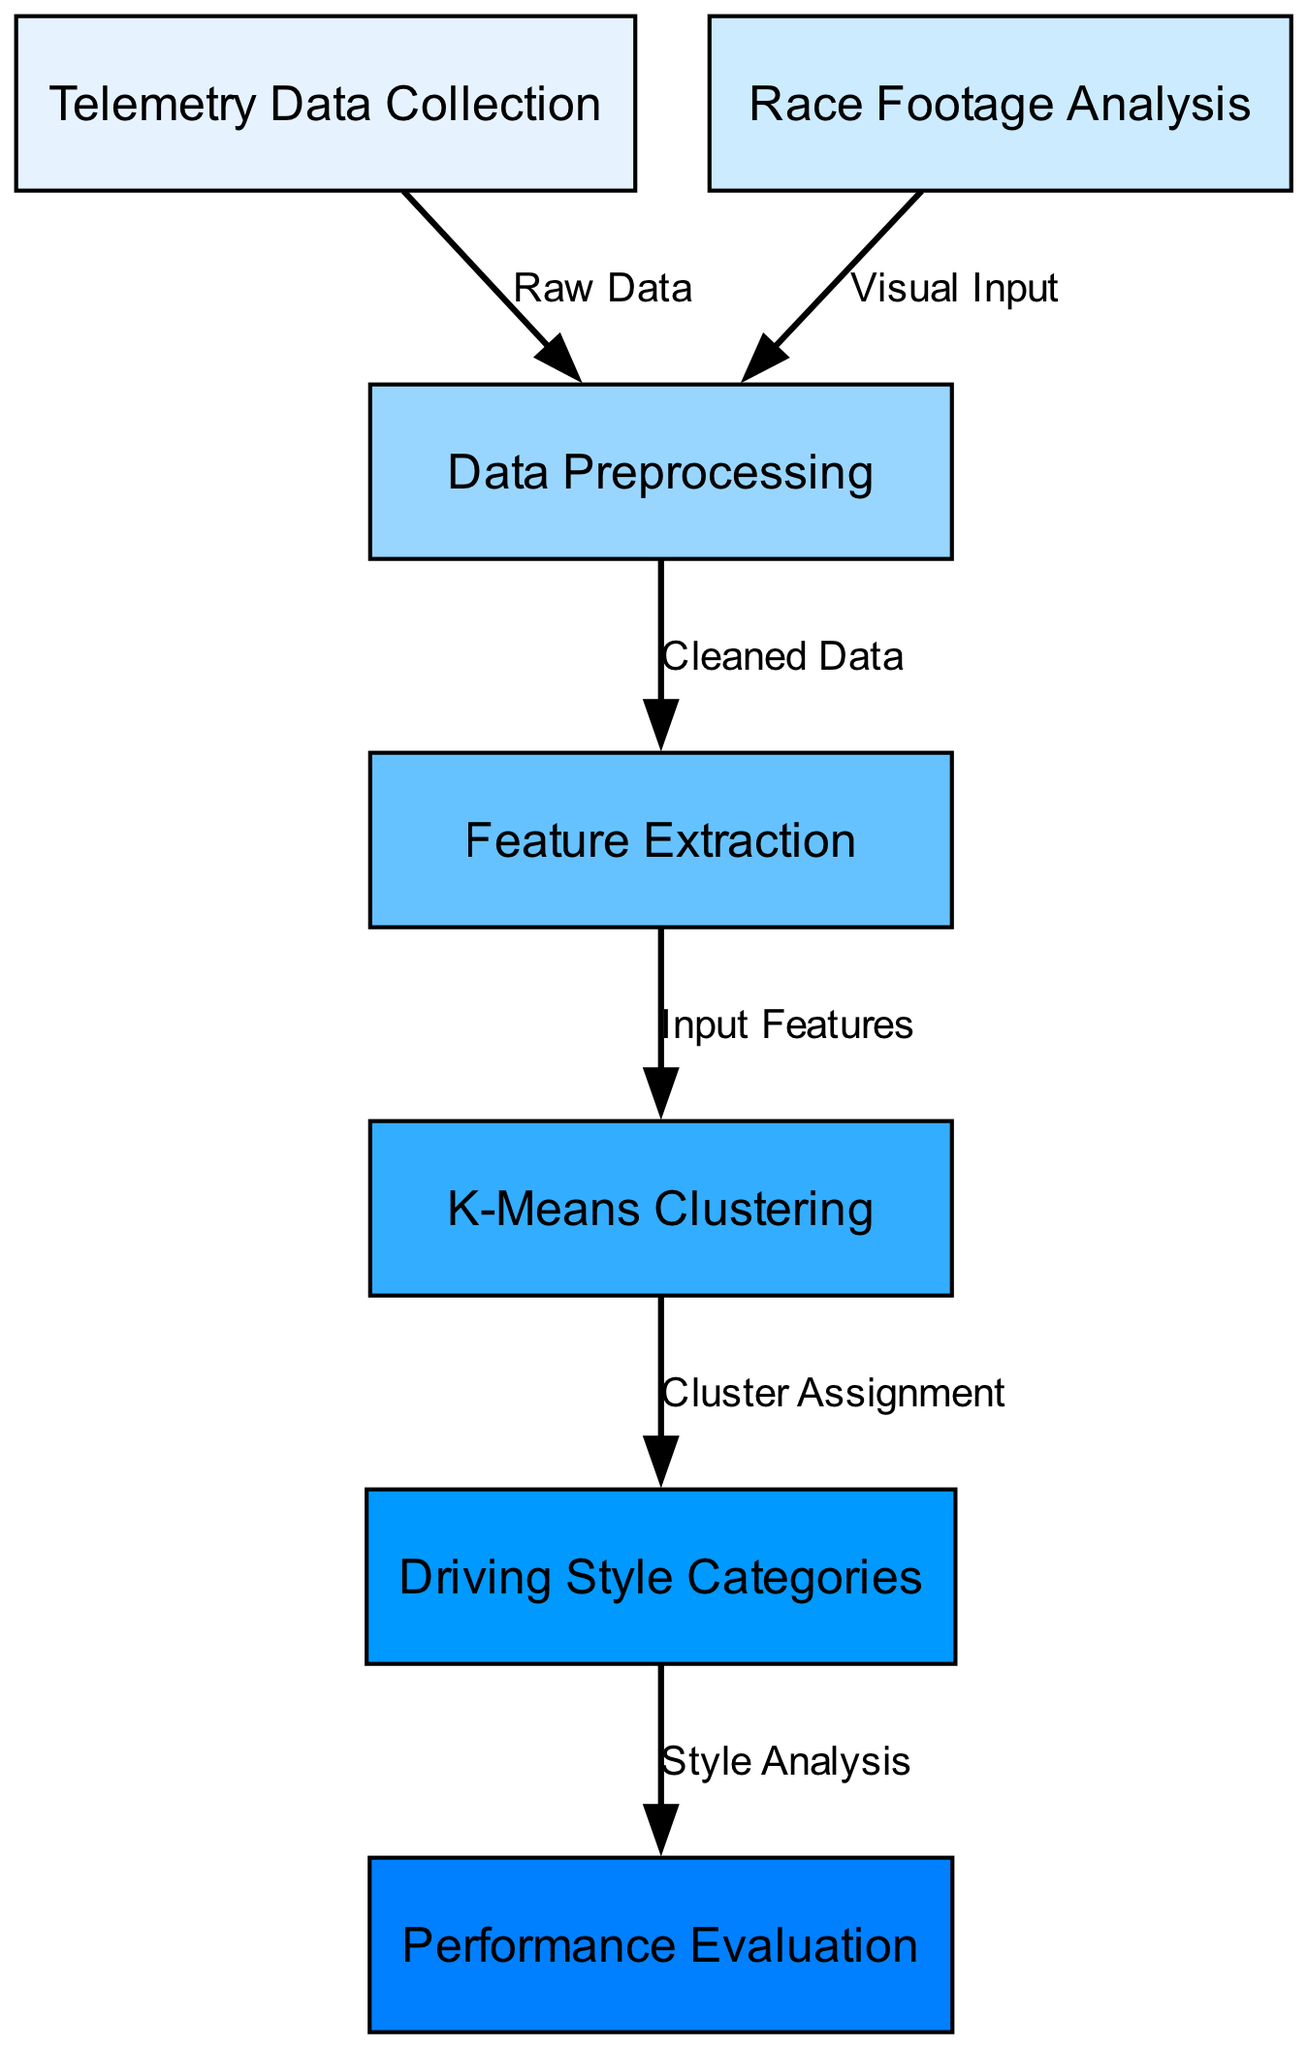What is the first node in the diagram? The first node is "Telemetry Data Collection," which is identified as the starting point of the process in the leftmost position of the diagram.
Answer: Telemetry Data Collection How many nodes are present in the diagram? The diagram contains a total of seven nodes, each representing a distinct component in the workflow.
Answer: 7 What type of data does the edge from node 1 represent? The edge from "Telemetry Data Collection" leads to "Data Preprocessing" and is labeled "Raw Data," indicating that the raw telemetry data is used for further processing.
Answer: Raw Data Which node receives input from both telemetry data and race footage? The "Data Preprocessing" node receives raw data from telemetry and visual input from race footage, which is pointed out by two incoming edges to that node.
Answer: Data Preprocessing What is the last node in the diagram? The last node is "Performance Evaluation," where the categorized driving styles are analyzed to assess their performance.
Answer: Performance Evaluation Which algorithm is used to categorize driving styles? The "K-Means Clustering" algorithm is applied in the diagram following feature extraction to categorize the driving styles based on the extracted features.
Answer: K-Means Clustering What is the relationship between "Feature Extraction" and "K-Means Clustering"? The edge connecting "Feature Extraction" to "K-Means Clustering" is labeled "Input Features," indicating that features extracted from cleaned data serve as input to the K-Means clustering algorithm.
Answer: Input Features How is the style analysis conducted? The style analysis is conducted in the "Driving Style Categories" node, which receives input from "K-Means Clustering" and represents the process of analyzing the assigned clusters to identify different driving styles.
Answer: Driving Style Categories 